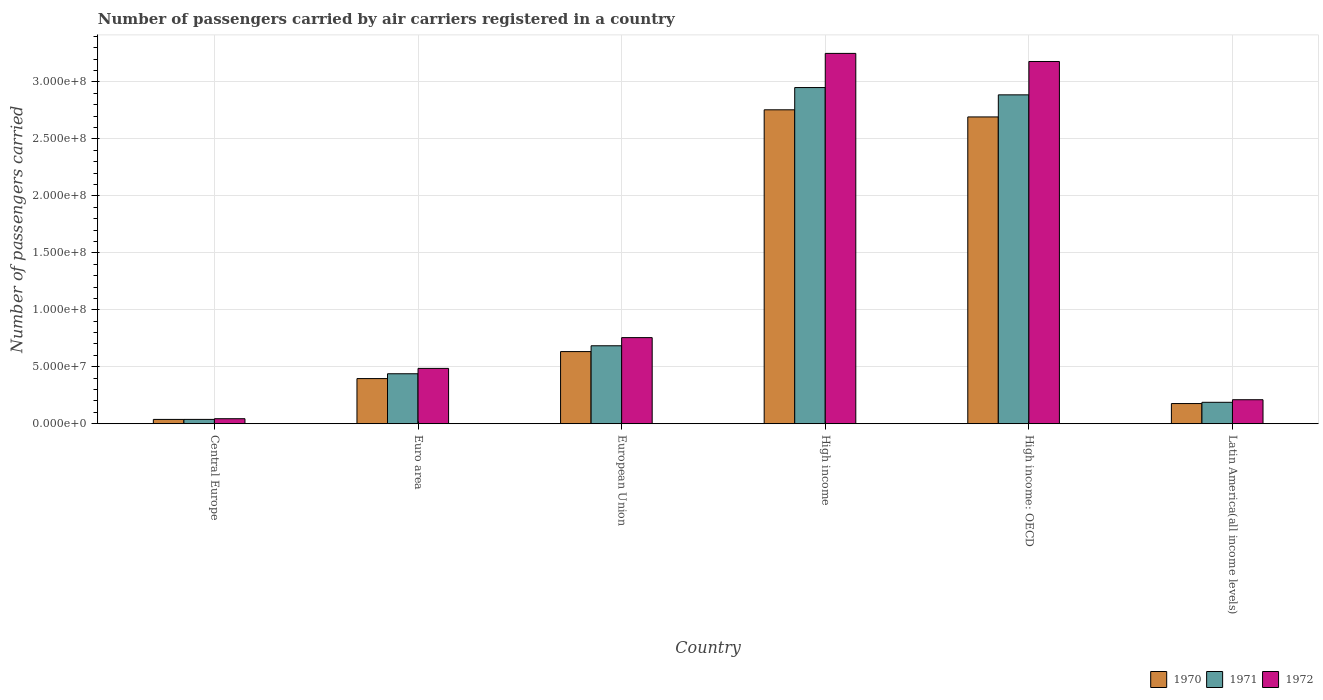How many different coloured bars are there?
Ensure brevity in your answer.  3. How many groups of bars are there?
Offer a very short reply. 6. Are the number of bars on each tick of the X-axis equal?
Your answer should be very brief. Yes. How many bars are there on the 1st tick from the left?
Offer a very short reply. 3. How many bars are there on the 2nd tick from the right?
Make the answer very short. 3. What is the label of the 5th group of bars from the left?
Offer a very short reply. High income: OECD. What is the number of passengers carried by air carriers in 1970 in High income: OECD?
Give a very brief answer. 2.69e+08. Across all countries, what is the maximum number of passengers carried by air carriers in 1970?
Make the answer very short. 2.76e+08. Across all countries, what is the minimum number of passengers carried by air carriers in 1970?
Give a very brief answer. 3.80e+06. In which country was the number of passengers carried by air carriers in 1971 minimum?
Provide a succinct answer. Central Europe. What is the total number of passengers carried by air carriers in 1972 in the graph?
Offer a very short reply. 7.93e+08. What is the difference between the number of passengers carried by air carriers in 1971 in High income and that in High income: OECD?
Your response must be concise. 6.40e+06. What is the difference between the number of passengers carried by air carriers in 1970 in Latin America(all income levels) and the number of passengers carried by air carriers in 1971 in European Union?
Provide a succinct answer. -5.07e+07. What is the average number of passengers carried by air carriers in 1971 per country?
Your response must be concise. 1.20e+08. What is the difference between the number of passengers carried by air carriers of/in 1970 and number of passengers carried by air carriers of/in 1971 in Latin America(all income levels)?
Offer a terse response. -1.09e+06. In how many countries, is the number of passengers carried by air carriers in 1971 greater than 70000000?
Provide a short and direct response. 2. What is the ratio of the number of passengers carried by air carriers in 1971 in High income: OECD to that in Latin America(all income levels)?
Your response must be concise. 15.35. Is the difference between the number of passengers carried by air carriers in 1970 in Euro area and High income greater than the difference between the number of passengers carried by air carriers in 1971 in Euro area and High income?
Offer a very short reply. Yes. What is the difference between the highest and the second highest number of passengers carried by air carriers in 1971?
Offer a very short reply. 6.40e+06. What is the difference between the highest and the lowest number of passengers carried by air carriers in 1971?
Your answer should be very brief. 2.91e+08. In how many countries, is the number of passengers carried by air carriers in 1970 greater than the average number of passengers carried by air carriers in 1970 taken over all countries?
Your response must be concise. 2. Are all the bars in the graph horizontal?
Offer a very short reply. No. How many countries are there in the graph?
Offer a terse response. 6. Are the values on the major ticks of Y-axis written in scientific E-notation?
Your answer should be very brief. Yes. Does the graph contain any zero values?
Offer a very short reply. No. Does the graph contain grids?
Ensure brevity in your answer.  Yes. Where does the legend appear in the graph?
Keep it short and to the point. Bottom right. How many legend labels are there?
Your response must be concise. 3. What is the title of the graph?
Offer a terse response. Number of passengers carried by air carriers registered in a country. What is the label or title of the Y-axis?
Provide a succinct answer. Number of passengers carried. What is the Number of passengers carried in 1970 in Central Europe?
Provide a succinct answer. 3.80e+06. What is the Number of passengers carried in 1971 in Central Europe?
Make the answer very short. 3.81e+06. What is the Number of passengers carried in 1972 in Central Europe?
Your answer should be very brief. 4.41e+06. What is the Number of passengers carried of 1970 in Euro area?
Ensure brevity in your answer.  3.96e+07. What is the Number of passengers carried in 1971 in Euro area?
Provide a succinct answer. 4.39e+07. What is the Number of passengers carried in 1972 in Euro area?
Offer a very short reply. 4.86e+07. What is the Number of passengers carried in 1970 in European Union?
Ensure brevity in your answer.  6.33e+07. What is the Number of passengers carried in 1971 in European Union?
Offer a very short reply. 6.84e+07. What is the Number of passengers carried in 1972 in European Union?
Your answer should be compact. 7.56e+07. What is the Number of passengers carried in 1970 in High income?
Your answer should be compact. 2.76e+08. What is the Number of passengers carried in 1971 in High income?
Keep it short and to the point. 2.95e+08. What is the Number of passengers carried of 1972 in High income?
Your response must be concise. 3.25e+08. What is the Number of passengers carried of 1970 in High income: OECD?
Your response must be concise. 2.69e+08. What is the Number of passengers carried of 1971 in High income: OECD?
Your answer should be very brief. 2.89e+08. What is the Number of passengers carried in 1972 in High income: OECD?
Provide a succinct answer. 3.18e+08. What is the Number of passengers carried of 1970 in Latin America(all income levels)?
Offer a terse response. 1.77e+07. What is the Number of passengers carried in 1971 in Latin America(all income levels)?
Your response must be concise. 1.88e+07. What is the Number of passengers carried in 1972 in Latin America(all income levels)?
Your answer should be compact. 2.11e+07. Across all countries, what is the maximum Number of passengers carried of 1970?
Provide a short and direct response. 2.76e+08. Across all countries, what is the maximum Number of passengers carried of 1971?
Your answer should be compact. 2.95e+08. Across all countries, what is the maximum Number of passengers carried of 1972?
Give a very brief answer. 3.25e+08. Across all countries, what is the minimum Number of passengers carried in 1970?
Provide a succinct answer. 3.80e+06. Across all countries, what is the minimum Number of passengers carried of 1971?
Keep it short and to the point. 3.81e+06. Across all countries, what is the minimum Number of passengers carried in 1972?
Offer a terse response. 4.41e+06. What is the total Number of passengers carried in 1970 in the graph?
Your answer should be compact. 6.69e+08. What is the total Number of passengers carried of 1971 in the graph?
Offer a very short reply. 7.19e+08. What is the total Number of passengers carried of 1972 in the graph?
Give a very brief answer. 7.93e+08. What is the difference between the Number of passengers carried of 1970 in Central Europe and that in Euro area?
Provide a short and direct response. -3.58e+07. What is the difference between the Number of passengers carried of 1971 in Central Europe and that in Euro area?
Offer a terse response. -4.01e+07. What is the difference between the Number of passengers carried of 1972 in Central Europe and that in Euro area?
Offer a terse response. -4.42e+07. What is the difference between the Number of passengers carried in 1970 in Central Europe and that in European Union?
Your response must be concise. -5.95e+07. What is the difference between the Number of passengers carried of 1971 in Central Europe and that in European Union?
Your response must be concise. -6.46e+07. What is the difference between the Number of passengers carried in 1972 in Central Europe and that in European Union?
Offer a very short reply. -7.12e+07. What is the difference between the Number of passengers carried in 1970 in Central Europe and that in High income?
Your response must be concise. -2.72e+08. What is the difference between the Number of passengers carried of 1971 in Central Europe and that in High income?
Provide a short and direct response. -2.91e+08. What is the difference between the Number of passengers carried in 1972 in Central Europe and that in High income?
Your answer should be compact. -3.21e+08. What is the difference between the Number of passengers carried in 1970 in Central Europe and that in High income: OECD?
Offer a very short reply. -2.66e+08. What is the difference between the Number of passengers carried in 1971 in Central Europe and that in High income: OECD?
Offer a very short reply. -2.85e+08. What is the difference between the Number of passengers carried in 1972 in Central Europe and that in High income: OECD?
Ensure brevity in your answer.  -3.14e+08. What is the difference between the Number of passengers carried of 1970 in Central Europe and that in Latin America(all income levels)?
Your answer should be compact. -1.39e+07. What is the difference between the Number of passengers carried of 1971 in Central Europe and that in Latin America(all income levels)?
Provide a short and direct response. -1.50e+07. What is the difference between the Number of passengers carried of 1972 in Central Europe and that in Latin America(all income levels)?
Provide a short and direct response. -1.67e+07. What is the difference between the Number of passengers carried in 1970 in Euro area and that in European Union?
Provide a succinct answer. -2.37e+07. What is the difference between the Number of passengers carried in 1971 in Euro area and that in European Union?
Give a very brief answer. -2.46e+07. What is the difference between the Number of passengers carried of 1972 in Euro area and that in European Union?
Offer a very short reply. -2.70e+07. What is the difference between the Number of passengers carried in 1970 in Euro area and that in High income?
Your answer should be compact. -2.36e+08. What is the difference between the Number of passengers carried of 1971 in Euro area and that in High income?
Ensure brevity in your answer.  -2.51e+08. What is the difference between the Number of passengers carried in 1972 in Euro area and that in High income?
Ensure brevity in your answer.  -2.77e+08. What is the difference between the Number of passengers carried of 1970 in Euro area and that in High income: OECD?
Provide a short and direct response. -2.30e+08. What is the difference between the Number of passengers carried in 1971 in Euro area and that in High income: OECD?
Offer a terse response. -2.45e+08. What is the difference between the Number of passengers carried in 1972 in Euro area and that in High income: OECD?
Make the answer very short. -2.69e+08. What is the difference between the Number of passengers carried in 1970 in Euro area and that in Latin America(all income levels)?
Your answer should be very brief. 2.19e+07. What is the difference between the Number of passengers carried in 1971 in Euro area and that in Latin America(all income levels)?
Offer a very short reply. 2.51e+07. What is the difference between the Number of passengers carried in 1972 in Euro area and that in Latin America(all income levels)?
Your answer should be very brief. 2.75e+07. What is the difference between the Number of passengers carried in 1970 in European Union and that in High income?
Offer a terse response. -2.12e+08. What is the difference between the Number of passengers carried of 1971 in European Union and that in High income?
Provide a short and direct response. -2.27e+08. What is the difference between the Number of passengers carried in 1972 in European Union and that in High income?
Your response must be concise. -2.50e+08. What is the difference between the Number of passengers carried of 1970 in European Union and that in High income: OECD?
Make the answer very short. -2.06e+08. What is the difference between the Number of passengers carried of 1971 in European Union and that in High income: OECD?
Offer a very short reply. -2.20e+08. What is the difference between the Number of passengers carried in 1972 in European Union and that in High income: OECD?
Ensure brevity in your answer.  -2.42e+08. What is the difference between the Number of passengers carried of 1970 in European Union and that in Latin America(all income levels)?
Provide a succinct answer. 4.56e+07. What is the difference between the Number of passengers carried of 1971 in European Union and that in Latin America(all income levels)?
Make the answer very short. 4.96e+07. What is the difference between the Number of passengers carried in 1972 in European Union and that in Latin America(all income levels)?
Your answer should be compact. 5.45e+07. What is the difference between the Number of passengers carried of 1970 in High income and that in High income: OECD?
Give a very brief answer. 6.26e+06. What is the difference between the Number of passengers carried of 1971 in High income and that in High income: OECD?
Provide a succinct answer. 6.40e+06. What is the difference between the Number of passengers carried in 1972 in High income and that in High income: OECD?
Make the answer very short. 7.11e+06. What is the difference between the Number of passengers carried in 1970 in High income and that in Latin America(all income levels)?
Your answer should be compact. 2.58e+08. What is the difference between the Number of passengers carried in 1971 in High income and that in Latin America(all income levels)?
Provide a succinct answer. 2.76e+08. What is the difference between the Number of passengers carried in 1972 in High income and that in Latin America(all income levels)?
Ensure brevity in your answer.  3.04e+08. What is the difference between the Number of passengers carried in 1970 in High income: OECD and that in Latin America(all income levels)?
Offer a terse response. 2.52e+08. What is the difference between the Number of passengers carried of 1971 in High income: OECD and that in Latin America(all income levels)?
Ensure brevity in your answer.  2.70e+08. What is the difference between the Number of passengers carried of 1972 in High income: OECD and that in Latin America(all income levels)?
Make the answer very short. 2.97e+08. What is the difference between the Number of passengers carried of 1970 in Central Europe and the Number of passengers carried of 1971 in Euro area?
Your answer should be compact. -4.01e+07. What is the difference between the Number of passengers carried of 1970 in Central Europe and the Number of passengers carried of 1972 in Euro area?
Keep it short and to the point. -4.48e+07. What is the difference between the Number of passengers carried of 1971 in Central Europe and the Number of passengers carried of 1972 in Euro area?
Your answer should be compact. -4.48e+07. What is the difference between the Number of passengers carried of 1970 in Central Europe and the Number of passengers carried of 1971 in European Union?
Keep it short and to the point. -6.46e+07. What is the difference between the Number of passengers carried of 1970 in Central Europe and the Number of passengers carried of 1972 in European Union?
Make the answer very short. -7.18e+07. What is the difference between the Number of passengers carried of 1971 in Central Europe and the Number of passengers carried of 1972 in European Union?
Keep it short and to the point. -7.18e+07. What is the difference between the Number of passengers carried in 1970 in Central Europe and the Number of passengers carried in 1971 in High income?
Your response must be concise. -2.91e+08. What is the difference between the Number of passengers carried in 1970 in Central Europe and the Number of passengers carried in 1972 in High income?
Your response must be concise. -3.21e+08. What is the difference between the Number of passengers carried of 1971 in Central Europe and the Number of passengers carried of 1972 in High income?
Your answer should be compact. -3.21e+08. What is the difference between the Number of passengers carried of 1970 in Central Europe and the Number of passengers carried of 1971 in High income: OECD?
Offer a terse response. -2.85e+08. What is the difference between the Number of passengers carried in 1970 in Central Europe and the Number of passengers carried in 1972 in High income: OECD?
Provide a short and direct response. -3.14e+08. What is the difference between the Number of passengers carried in 1971 in Central Europe and the Number of passengers carried in 1972 in High income: OECD?
Offer a terse response. -3.14e+08. What is the difference between the Number of passengers carried in 1970 in Central Europe and the Number of passengers carried in 1971 in Latin America(all income levels)?
Your response must be concise. -1.50e+07. What is the difference between the Number of passengers carried in 1970 in Central Europe and the Number of passengers carried in 1972 in Latin America(all income levels)?
Provide a short and direct response. -1.73e+07. What is the difference between the Number of passengers carried of 1971 in Central Europe and the Number of passengers carried of 1972 in Latin America(all income levels)?
Ensure brevity in your answer.  -1.73e+07. What is the difference between the Number of passengers carried of 1970 in Euro area and the Number of passengers carried of 1971 in European Union?
Give a very brief answer. -2.88e+07. What is the difference between the Number of passengers carried of 1970 in Euro area and the Number of passengers carried of 1972 in European Union?
Your response must be concise. -3.60e+07. What is the difference between the Number of passengers carried in 1971 in Euro area and the Number of passengers carried in 1972 in European Union?
Provide a short and direct response. -3.17e+07. What is the difference between the Number of passengers carried in 1970 in Euro area and the Number of passengers carried in 1971 in High income?
Your response must be concise. -2.55e+08. What is the difference between the Number of passengers carried in 1970 in Euro area and the Number of passengers carried in 1972 in High income?
Offer a terse response. -2.85e+08. What is the difference between the Number of passengers carried in 1971 in Euro area and the Number of passengers carried in 1972 in High income?
Give a very brief answer. -2.81e+08. What is the difference between the Number of passengers carried in 1970 in Euro area and the Number of passengers carried in 1971 in High income: OECD?
Keep it short and to the point. -2.49e+08. What is the difference between the Number of passengers carried of 1970 in Euro area and the Number of passengers carried of 1972 in High income: OECD?
Ensure brevity in your answer.  -2.78e+08. What is the difference between the Number of passengers carried of 1971 in Euro area and the Number of passengers carried of 1972 in High income: OECD?
Offer a terse response. -2.74e+08. What is the difference between the Number of passengers carried of 1970 in Euro area and the Number of passengers carried of 1971 in Latin America(all income levels)?
Offer a very short reply. 2.08e+07. What is the difference between the Number of passengers carried of 1970 in Euro area and the Number of passengers carried of 1972 in Latin America(all income levels)?
Ensure brevity in your answer.  1.86e+07. What is the difference between the Number of passengers carried in 1971 in Euro area and the Number of passengers carried in 1972 in Latin America(all income levels)?
Offer a terse response. 2.28e+07. What is the difference between the Number of passengers carried in 1970 in European Union and the Number of passengers carried in 1971 in High income?
Make the answer very short. -2.32e+08. What is the difference between the Number of passengers carried in 1970 in European Union and the Number of passengers carried in 1972 in High income?
Your answer should be very brief. -2.62e+08. What is the difference between the Number of passengers carried of 1971 in European Union and the Number of passengers carried of 1972 in High income?
Your answer should be very brief. -2.57e+08. What is the difference between the Number of passengers carried of 1970 in European Union and the Number of passengers carried of 1971 in High income: OECD?
Keep it short and to the point. -2.25e+08. What is the difference between the Number of passengers carried in 1970 in European Union and the Number of passengers carried in 1972 in High income: OECD?
Provide a succinct answer. -2.55e+08. What is the difference between the Number of passengers carried in 1971 in European Union and the Number of passengers carried in 1972 in High income: OECD?
Provide a short and direct response. -2.50e+08. What is the difference between the Number of passengers carried of 1970 in European Union and the Number of passengers carried of 1971 in Latin America(all income levels)?
Offer a very short reply. 4.45e+07. What is the difference between the Number of passengers carried of 1970 in European Union and the Number of passengers carried of 1972 in Latin America(all income levels)?
Make the answer very short. 4.23e+07. What is the difference between the Number of passengers carried in 1971 in European Union and the Number of passengers carried in 1972 in Latin America(all income levels)?
Keep it short and to the point. 4.74e+07. What is the difference between the Number of passengers carried of 1970 in High income and the Number of passengers carried of 1971 in High income: OECD?
Ensure brevity in your answer.  -1.31e+07. What is the difference between the Number of passengers carried in 1970 in High income and the Number of passengers carried in 1972 in High income: OECD?
Keep it short and to the point. -4.24e+07. What is the difference between the Number of passengers carried of 1971 in High income and the Number of passengers carried of 1972 in High income: OECD?
Provide a succinct answer. -2.29e+07. What is the difference between the Number of passengers carried of 1970 in High income and the Number of passengers carried of 1971 in Latin America(all income levels)?
Offer a very short reply. 2.57e+08. What is the difference between the Number of passengers carried in 1970 in High income and the Number of passengers carried in 1972 in Latin America(all income levels)?
Make the answer very short. 2.55e+08. What is the difference between the Number of passengers carried of 1971 in High income and the Number of passengers carried of 1972 in Latin America(all income levels)?
Make the answer very short. 2.74e+08. What is the difference between the Number of passengers carried in 1970 in High income: OECD and the Number of passengers carried in 1971 in Latin America(all income levels)?
Offer a terse response. 2.51e+08. What is the difference between the Number of passengers carried of 1970 in High income: OECD and the Number of passengers carried of 1972 in Latin America(all income levels)?
Offer a very short reply. 2.48e+08. What is the difference between the Number of passengers carried of 1971 in High income: OECD and the Number of passengers carried of 1972 in Latin America(all income levels)?
Keep it short and to the point. 2.68e+08. What is the average Number of passengers carried of 1970 per country?
Your response must be concise. 1.12e+08. What is the average Number of passengers carried in 1971 per country?
Make the answer very short. 1.20e+08. What is the average Number of passengers carried of 1972 per country?
Provide a succinct answer. 1.32e+08. What is the difference between the Number of passengers carried of 1970 and Number of passengers carried of 1971 in Central Europe?
Your response must be concise. -6900. What is the difference between the Number of passengers carried in 1970 and Number of passengers carried in 1972 in Central Europe?
Offer a very short reply. -6.12e+05. What is the difference between the Number of passengers carried in 1971 and Number of passengers carried in 1972 in Central Europe?
Give a very brief answer. -6.05e+05. What is the difference between the Number of passengers carried of 1970 and Number of passengers carried of 1971 in Euro area?
Ensure brevity in your answer.  -4.23e+06. What is the difference between the Number of passengers carried of 1970 and Number of passengers carried of 1972 in Euro area?
Make the answer very short. -8.94e+06. What is the difference between the Number of passengers carried of 1971 and Number of passengers carried of 1972 in Euro area?
Provide a succinct answer. -4.71e+06. What is the difference between the Number of passengers carried in 1970 and Number of passengers carried in 1971 in European Union?
Make the answer very short. -5.11e+06. What is the difference between the Number of passengers carried in 1970 and Number of passengers carried in 1972 in European Union?
Offer a terse response. -1.23e+07. What is the difference between the Number of passengers carried in 1971 and Number of passengers carried in 1972 in European Union?
Your answer should be compact. -7.16e+06. What is the difference between the Number of passengers carried of 1970 and Number of passengers carried of 1971 in High income?
Your answer should be very brief. -1.95e+07. What is the difference between the Number of passengers carried of 1970 and Number of passengers carried of 1972 in High income?
Keep it short and to the point. -4.95e+07. What is the difference between the Number of passengers carried in 1971 and Number of passengers carried in 1972 in High income?
Ensure brevity in your answer.  -3.00e+07. What is the difference between the Number of passengers carried of 1970 and Number of passengers carried of 1971 in High income: OECD?
Your answer should be compact. -1.94e+07. What is the difference between the Number of passengers carried in 1970 and Number of passengers carried in 1972 in High income: OECD?
Your answer should be compact. -4.87e+07. What is the difference between the Number of passengers carried of 1971 and Number of passengers carried of 1972 in High income: OECD?
Ensure brevity in your answer.  -2.93e+07. What is the difference between the Number of passengers carried in 1970 and Number of passengers carried in 1971 in Latin America(all income levels)?
Your answer should be very brief. -1.09e+06. What is the difference between the Number of passengers carried in 1970 and Number of passengers carried in 1972 in Latin America(all income levels)?
Offer a terse response. -3.36e+06. What is the difference between the Number of passengers carried of 1971 and Number of passengers carried of 1972 in Latin America(all income levels)?
Offer a terse response. -2.27e+06. What is the ratio of the Number of passengers carried of 1970 in Central Europe to that in Euro area?
Provide a succinct answer. 0.1. What is the ratio of the Number of passengers carried of 1971 in Central Europe to that in Euro area?
Keep it short and to the point. 0.09. What is the ratio of the Number of passengers carried of 1972 in Central Europe to that in Euro area?
Make the answer very short. 0.09. What is the ratio of the Number of passengers carried in 1970 in Central Europe to that in European Union?
Provide a short and direct response. 0.06. What is the ratio of the Number of passengers carried in 1971 in Central Europe to that in European Union?
Offer a very short reply. 0.06. What is the ratio of the Number of passengers carried in 1972 in Central Europe to that in European Union?
Your answer should be very brief. 0.06. What is the ratio of the Number of passengers carried of 1970 in Central Europe to that in High income?
Your answer should be compact. 0.01. What is the ratio of the Number of passengers carried of 1971 in Central Europe to that in High income?
Your response must be concise. 0.01. What is the ratio of the Number of passengers carried of 1972 in Central Europe to that in High income?
Your answer should be very brief. 0.01. What is the ratio of the Number of passengers carried of 1970 in Central Europe to that in High income: OECD?
Your answer should be compact. 0.01. What is the ratio of the Number of passengers carried of 1971 in Central Europe to that in High income: OECD?
Your response must be concise. 0.01. What is the ratio of the Number of passengers carried of 1972 in Central Europe to that in High income: OECD?
Keep it short and to the point. 0.01. What is the ratio of the Number of passengers carried of 1970 in Central Europe to that in Latin America(all income levels)?
Ensure brevity in your answer.  0.21. What is the ratio of the Number of passengers carried of 1971 in Central Europe to that in Latin America(all income levels)?
Your answer should be very brief. 0.2. What is the ratio of the Number of passengers carried in 1972 in Central Europe to that in Latin America(all income levels)?
Provide a succinct answer. 0.21. What is the ratio of the Number of passengers carried in 1970 in Euro area to that in European Union?
Your response must be concise. 0.63. What is the ratio of the Number of passengers carried of 1971 in Euro area to that in European Union?
Keep it short and to the point. 0.64. What is the ratio of the Number of passengers carried of 1972 in Euro area to that in European Union?
Offer a very short reply. 0.64. What is the ratio of the Number of passengers carried of 1970 in Euro area to that in High income?
Your answer should be very brief. 0.14. What is the ratio of the Number of passengers carried in 1971 in Euro area to that in High income?
Your answer should be compact. 0.15. What is the ratio of the Number of passengers carried of 1972 in Euro area to that in High income?
Your answer should be very brief. 0.15. What is the ratio of the Number of passengers carried of 1970 in Euro area to that in High income: OECD?
Offer a terse response. 0.15. What is the ratio of the Number of passengers carried of 1971 in Euro area to that in High income: OECD?
Ensure brevity in your answer.  0.15. What is the ratio of the Number of passengers carried of 1972 in Euro area to that in High income: OECD?
Offer a terse response. 0.15. What is the ratio of the Number of passengers carried of 1970 in Euro area to that in Latin America(all income levels)?
Offer a very short reply. 2.24. What is the ratio of the Number of passengers carried in 1971 in Euro area to that in Latin America(all income levels)?
Your answer should be compact. 2.33. What is the ratio of the Number of passengers carried in 1972 in Euro area to that in Latin America(all income levels)?
Provide a succinct answer. 2.3. What is the ratio of the Number of passengers carried in 1970 in European Union to that in High income?
Your answer should be compact. 0.23. What is the ratio of the Number of passengers carried of 1971 in European Union to that in High income?
Keep it short and to the point. 0.23. What is the ratio of the Number of passengers carried of 1972 in European Union to that in High income?
Your answer should be very brief. 0.23. What is the ratio of the Number of passengers carried of 1970 in European Union to that in High income: OECD?
Make the answer very short. 0.24. What is the ratio of the Number of passengers carried in 1971 in European Union to that in High income: OECD?
Provide a succinct answer. 0.24. What is the ratio of the Number of passengers carried of 1972 in European Union to that in High income: OECD?
Offer a terse response. 0.24. What is the ratio of the Number of passengers carried in 1970 in European Union to that in Latin America(all income levels)?
Offer a very short reply. 3.57. What is the ratio of the Number of passengers carried of 1971 in European Union to that in Latin America(all income levels)?
Offer a terse response. 3.64. What is the ratio of the Number of passengers carried of 1972 in European Union to that in Latin America(all income levels)?
Keep it short and to the point. 3.59. What is the ratio of the Number of passengers carried in 1970 in High income to that in High income: OECD?
Ensure brevity in your answer.  1.02. What is the ratio of the Number of passengers carried in 1971 in High income to that in High income: OECD?
Your answer should be compact. 1.02. What is the ratio of the Number of passengers carried of 1972 in High income to that in High income: OECD?
Your response must be concise. 1.02. What is the ratio of the Number of passengers carried in 1970 in High income to that in Latin America(all income levels)?
Give a very brief answer. 15.55. What is the ratio of the Number of passengers carried of 1971 in High income to that in Latin America(all income levels)?
Your answer should be very brief. 15.69. What is the ratio of the Number of passengers carried of 1972 in High income to that in Latin America(all income levels)?
Give a very brief answer. 15.42. What is the ratio of the Number of passengers carried of 1970 in High income: OECD to that in Latin America(all income levels)?
Ensure brevity in your answer.  15.2. What is the ratio of the Number of passengers carried of 1971 in High income: OECD to that in Latin America(all income levels)?
Keep it short and to the point. 15.35. What is the ratio of the Number of passengers carried in 1972 in High income: OECD to that in Latin America(all income levels)?
Offer a terse response. 15.09. What is the difference between the highest and the second highest Number of passengers carried of 1970?
Provide a succinct answer. 6.26e+06. What is the difference between the highest and the second highest Number of passengers carried of 1971?
Ensure brevity in your answer.  6.40e+06. What is the difference between the highest and the second highest Number of passengers carried in 1972?
Keep it short and to the point. 7.11e+06. What is the difference between the highest and the lowest Number of passengers carried of 1970?
Your answer should be very brief. 2.72e+08. What is the difference between the highest and the lowest Number of passengers carried of 1971?
Make the answer very short. 2.91e+08. What is the difference between the highest and the lowest Number of passengers carried in 1972?
Offer a terse response. 3.21e+08. 